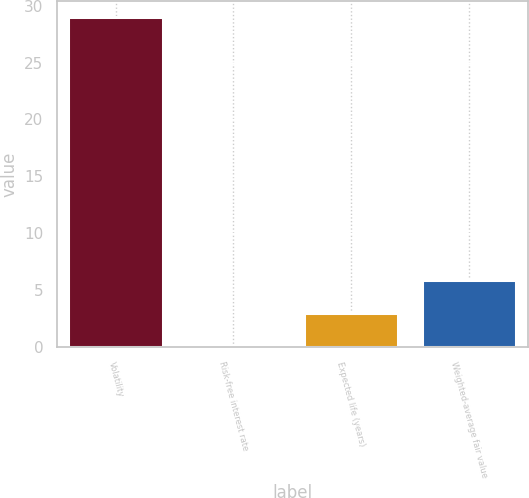Convert chart to OTSL. <chart><loc_0><loc_0><loc_500><loc_500><bar_chart><fcel>Volatility<fcel>Risk-free interest rate<fcel>Expected life (years)<fcel>Weighted-average fair value<nl><fcel>29<fcel>0.1<fcel>2.99<fcel>5.88<nl></chart> 